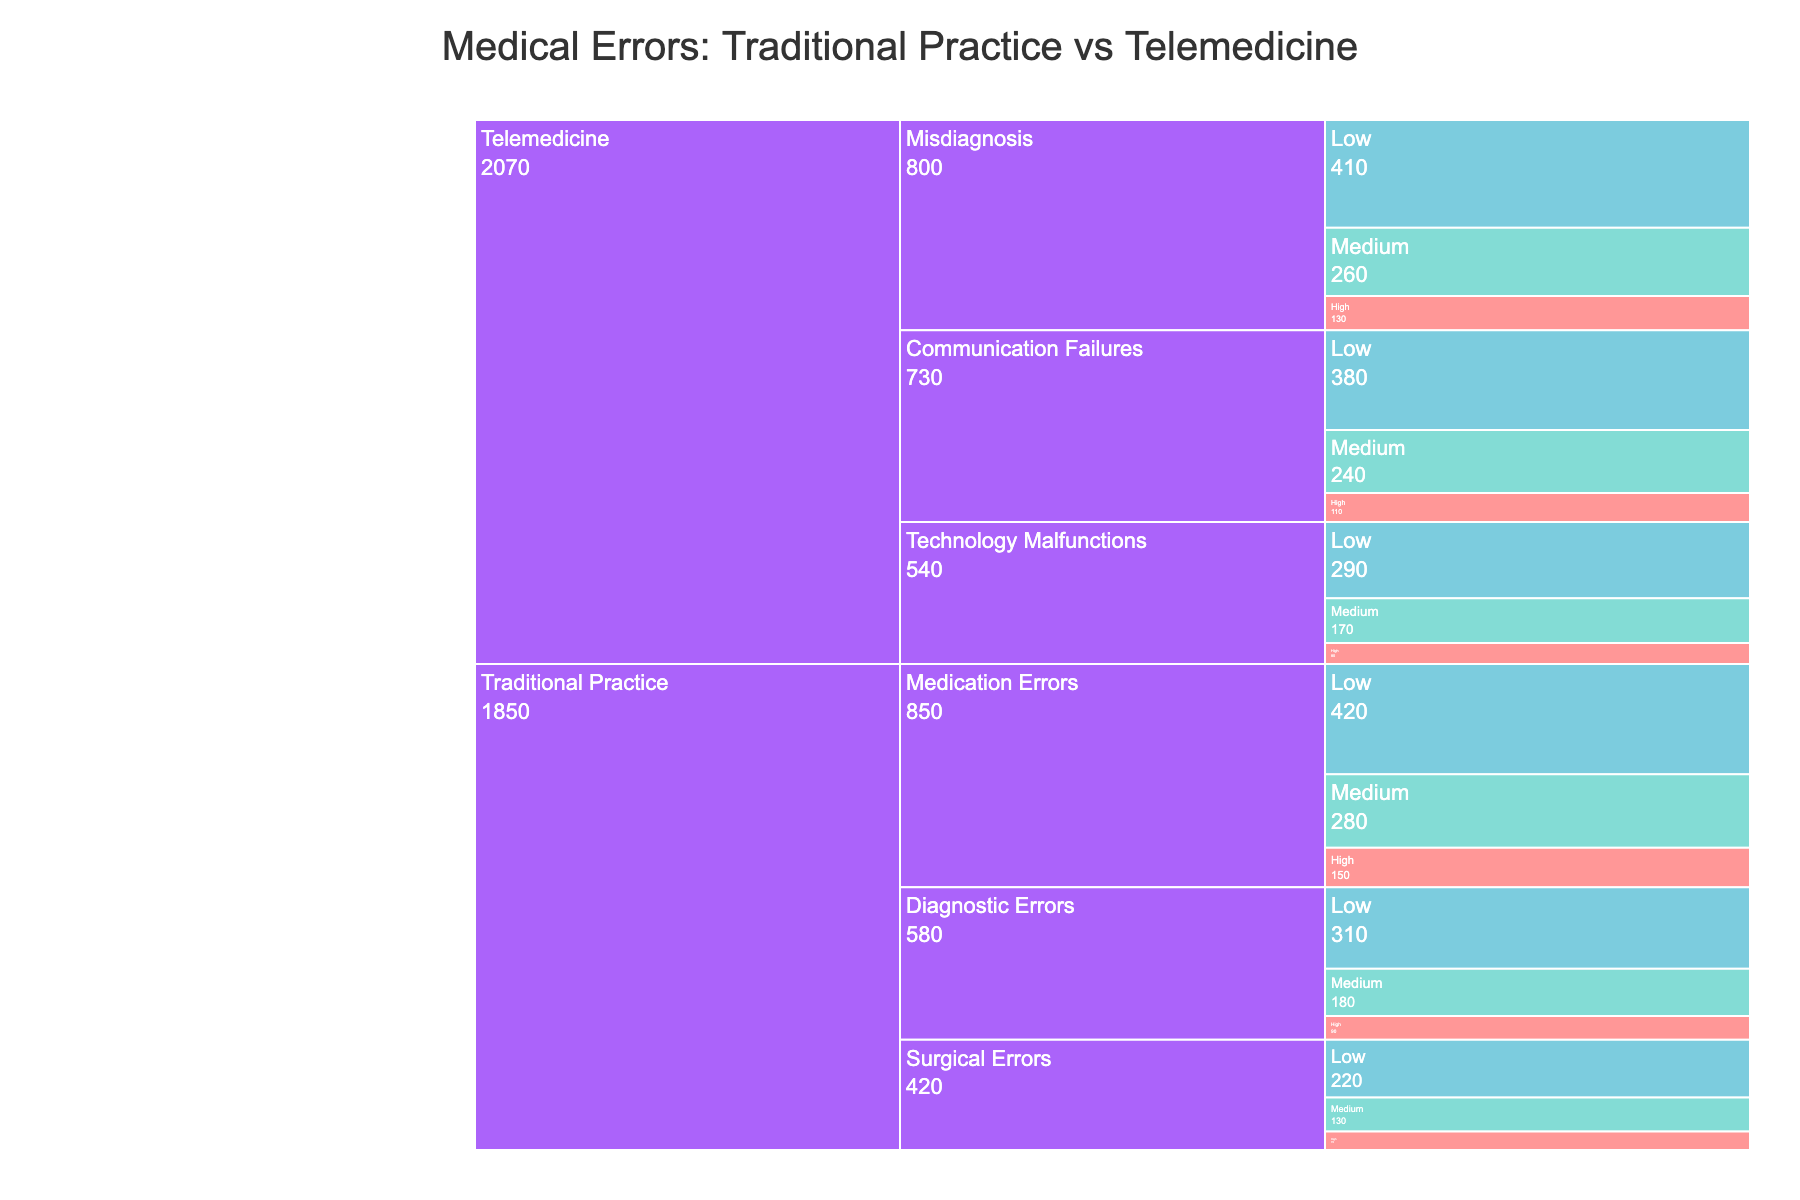What's the title of the figure? The title of the figure is typically displayed at the top and provides a summary of what the chart represents. In this case, it reads "Medical Errors: Traditional Practice vs Telemedicine".
Answer: Medical Errors: Traditional Practice vs Telemedicine Which category has the highest frequency of medical errors? To find this, look at which section of the Icicle chart has the largest combined value across all severities within a category. Calculate the sum for both categories: Traditional Practice and Telemedicine. Traditional Practice: (150 + 280 + 420 + 90 + 180 + 310 + 70 + 130 + 220) = 1850, Telemedicine: (110 + 240 + 380 + 80 + 170 + 290 + 130 + 260 + 410) = 2070. Telemedicine has the higher frequency.
Answer: Telemedicine What is the total frequency of low-severity medication errors in traditional practice? In the Icicle chart, locate the section for Traditional Practice, then Medication Errors, and find the Low severity. The value there is the frequency.
Answer: 420 Which type of error has the highest frequency in telemedicine? Look at the subcategories under Telemedicine and identify the type of error with the highest total frequency across all severities. Misdiagnosis: (130 + 260 + 410) = 800, Communication Failures: (110 + 240 + 380) = 730, Technology Malfunctions: (80 + 170 + 290) = 540. Misdiagnosis has the highest frequency.
Answer: Misdiagnosis Compare the frequency of high-severity medical errors in both categories. Which one is higher? Identify the High-severity frequency values for Traditional Practice (sum up Medication Errors: 150, Diagnostic Errors: 90, Surgical Errors: 70) and Telemedicine (sum up Communication Failures: 110, Technology Malfunctions: 80, Misdiagnosis: 130). Total for Traditional Practice is (150 + 90 + 70) = 310, and for Telemedicine is (110 + 80 + 130) = 320. Telemedicine has a higher frequency.
Answer: Telemedicine What fraction of the errors in traditional practice are surgical errors? Calculate the sum of all errors in Traditional Practice and then the sum of surgical errors: Total errors in Traditional Practice = 1850. Surgical Errors = (70 + 130 + 220) = 420. The fraction is 420/1850. Simplify the fraction if possible.
Answer: 0.23 (23/100) Which has more medium-severity errors, Traditional Practice or Telemedicine? Locate the Medium-severity sections for both Traditional Practice (Sum of Medication Errors: 280, Diagnostic Errors: 180, Surgical Errors: 130) and Telemedicine (Sum of Communication Failures: 240, Technology Malfunctions: 170, Misdiagnosis: 260). Traditional Practice: 280+180+130 = 590, Telemedicine: 240+170+260 = 670. Telemedicine has more medium-severity errors.
Answer: Telemedicine How does the frequency of technology malfunctions in telemedicine compare to the frequency of surgical errors in traditional practice? Sum up the frequencies for Technology Malfunctions in Telemedicine (80 + 170 + 290 = 540) and Surgical Errors in Traditional Practice (70 + 130 + 220 = 420). Compare the two sums.
Answer: Technology malfunctions are higher 